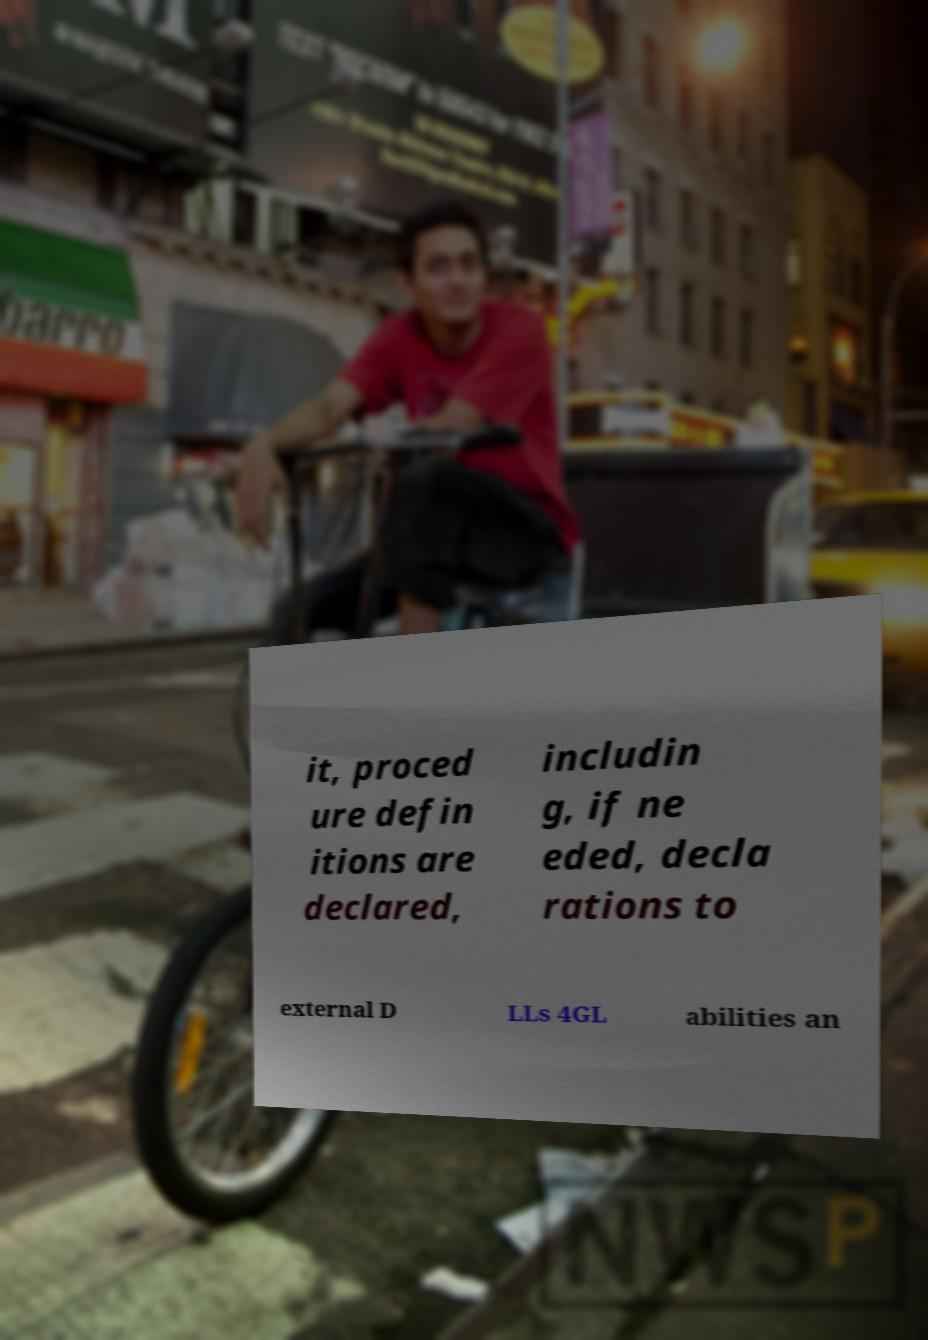Please identify and transcribe the text found in this image. it, proced ure defin itions are declared, includin g, if ne eded, decla rations to external D LLs 4GL abilities an 